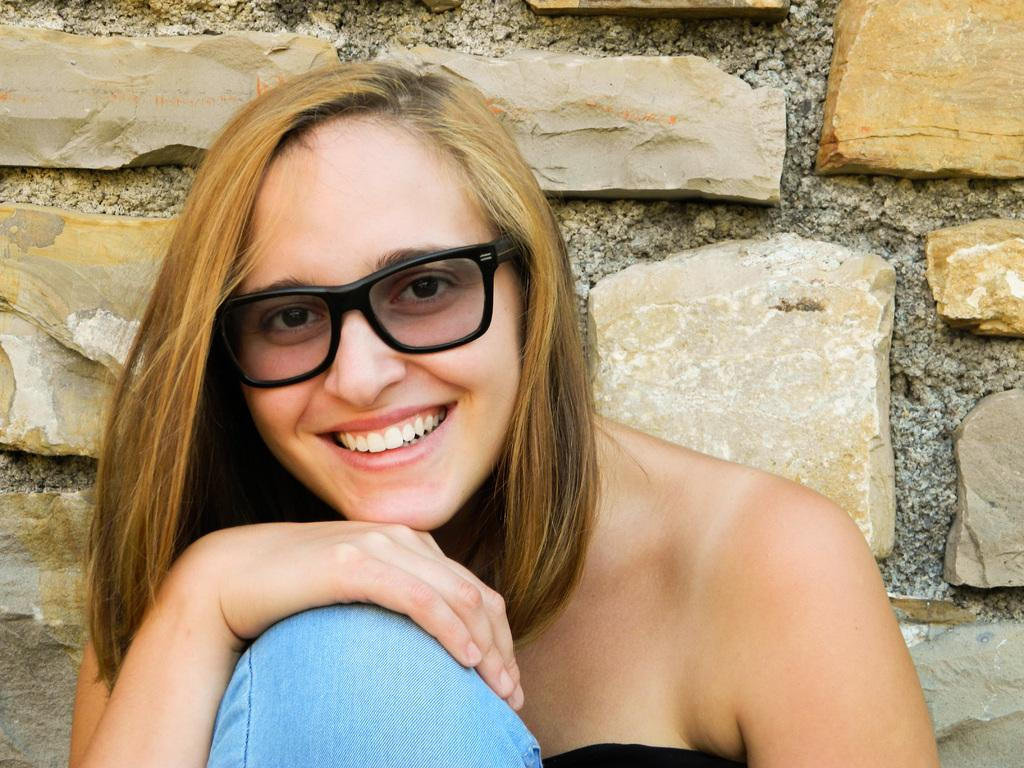Who is present in the image? There is a woman in the image. What is the woman's facial expression? The woman is smiling. What can be seen in the background of the image? There is a wall in the background of the image. What type of feather is the woman holding in the image? There is no feather present in the image; the woman is not holding anything. 